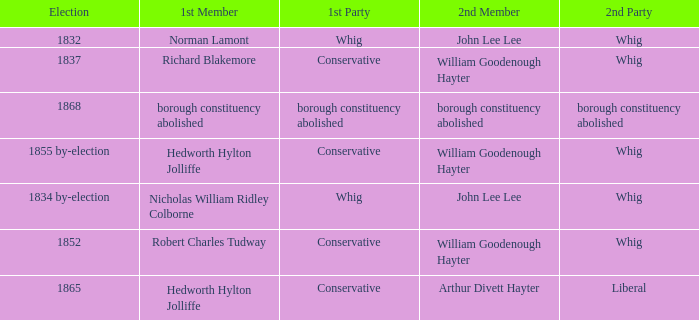Who's the conservative 1st member of the election of 1852? Robert Charles Tudway. 